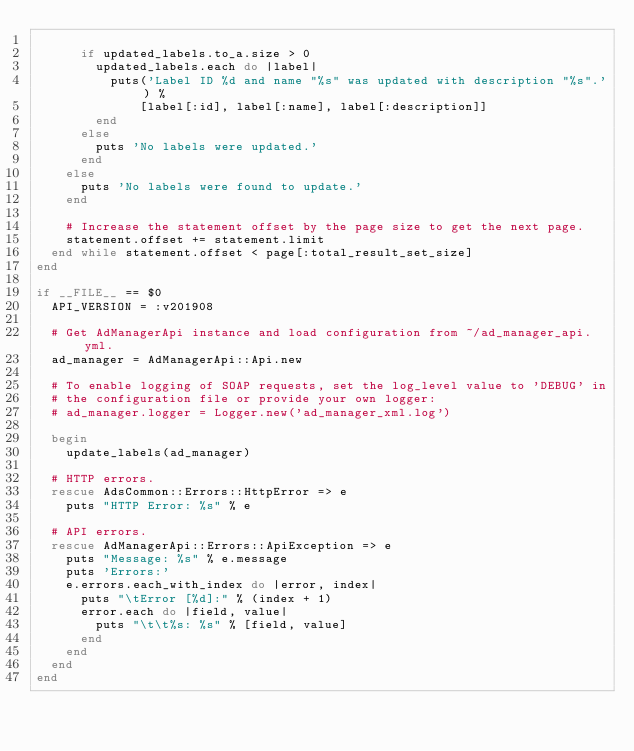<code> <loc_0><loc_0><loc_500><loc_500><_Ruby_>
      if updated_labels.to_a.size > 0
        updated_labels.each do |label|
          puts('Label ID %d and name "%s" was updated with description "%s".') %
              [label[:id], label[:name], label[:description]]
        end
      else
        puts 'No labels were updated.'
      end
    else
      puts 'No labels were found to update.'
    end

    # Increase the statement offset by the page size to get the next page.
    statement.offset += statement.limit
  end while statement.offset < page[:total_result_set_size]
end

if __FILE__ == $0
  API_VERSION = :v201908

  # Get AdManagerApi instance and load configuration from ~/ad_manager_api.yml.
  ad_manager = AdManagerApi::Api.new

  # To enable logging of SOAP requests, set the log_level value to 'DEBUG' in
  # the configuration file or provide your own logger:
  # ad_manager.logger = Logger.new('ad_manager_xml.log')

  begin
    update_labels(ad_manager)

  # HTTP errors.
  rescue AdsCommon::Errors::HttpError => e
    puts "HTTP Error: %s" % e

  # API errors.
  rescue AdManagerApi::Errors::ApiException => e
    puts "Message: %s" % e.message
    puts 'Errors:'
    e.errors.each_with_index do |error, index|
      puts "\tError [%d]:" % (index + 1)
      error.each do |field, value|
        puts "\t\t%s: %s" % [field, value]
      end
    end
  end
end
</code> 